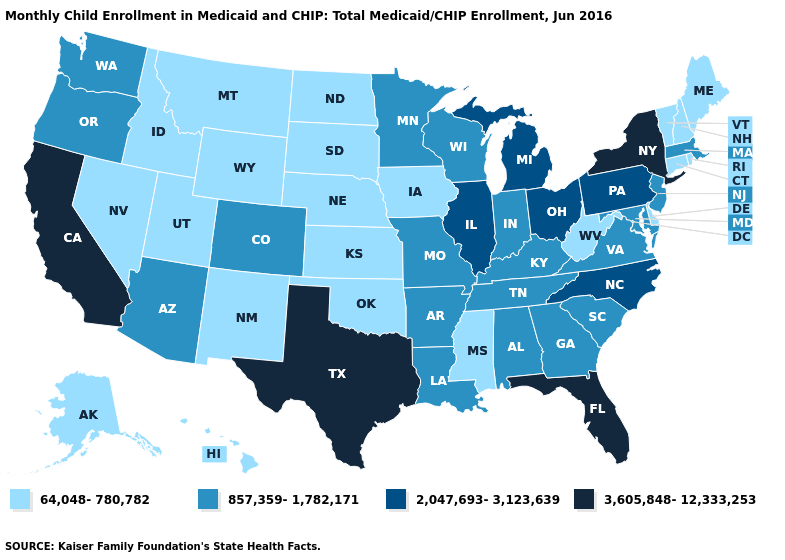Among the states that border Vermont , does New Hampshire have the highest value?
Be succinct. No. Does the first symbol in the legend represent the smallest category?
Short answer required. Yes. Name the states that have a value in the range 2,047,693-3,123,639?
Give a very brief answer. Illinois, Michigan, North Carolina, Ohio, Pennsylvania. Does the map have missing data?
Be succinct. No. What is the lowest value in the West?
Keep it brief. 64,048-780,782. Which states have the lowest value in the MidWest?
Short answer required. Iowa, Kansas, Nebraska, North Dakota, South Dakota. Among the states that border Missouri , which have the highest value?
Give a very brief answer. Illinois. What is the value of New Jersey?
Concise answer only. 857,359-1,782,171. Does California have the same value as Hawaii?
Concise answer only. No. Does South Carolina have the lowest value in the USA?
Keep it brief. No. What is the lowest value in the USA?
Short answer required. 64,048-780,782. What is the value of Washington?
Quick response, please. 857,359-1,782,171. What is the value of Maine?
Write a very short answer. 64,048-780,782. Does Connecticut have a lower value than Wisconsin?
Concise answer only. Yes. 